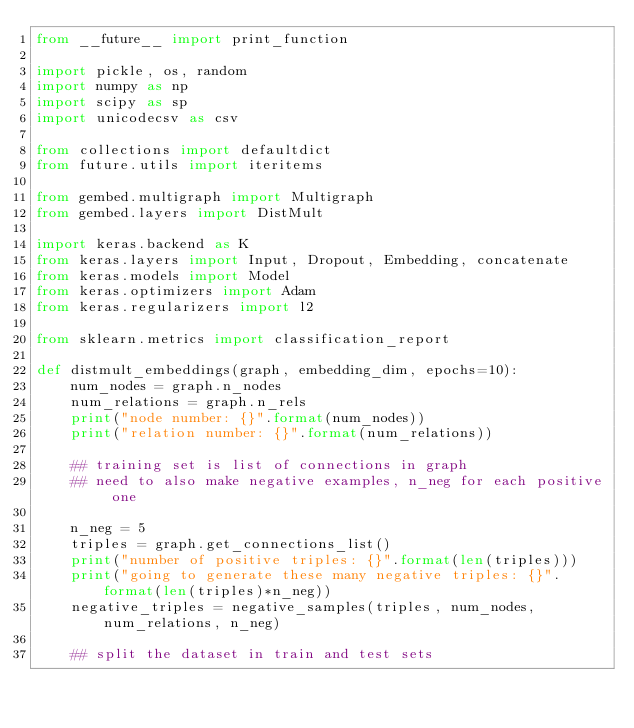<code> <loc_0><loc_0><loc_500><loc_500><_Python_>from __future__ import print_function

import pickle, os, random
import numpy as np
import scipy as sp
import unicodecsv as csv

from collections import defaultdict
from future.utils import iteritems

from gembed.multigraph import Multigraph
from gembed.layers import DistMult

import keras.backend as K
from keras.layers import Input, Dropout, Embedding, concatenate
from keras.models import Model
from keras.optimizers import Adam
from keras.regularizers import l2

from sklearn.metrics import classification_report

def distmult_embeddings(graph, embedding_dim, epochs=10):
    num_nodes = graph.n_nodes
    num_relations = graph.n_rels
    print("node number: {}".format(num_nodes))
    print("relation number: {}".format(num_relations))

    ## training set is list of connections in graph
    ## need to also make negative examples, n_neg for each positive one

    n_neg = 5
    triples = graph.get_connections_list()
    print("number of positive triples: {}".format(len(triples)))
    print("going to generate these many negative triples: {}".format(len(triples)*n_neg))
    negative_triples = negative_samples(triples, num_nodes, num_relations, n_neg)
    
    ## split the dataset in train and test sets</code> 